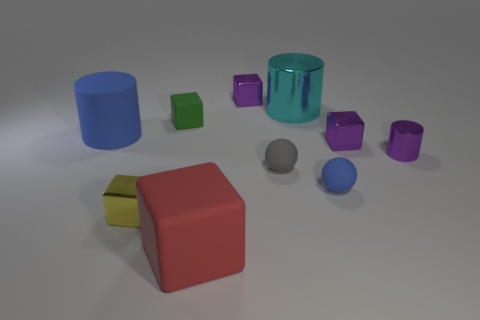How many things are either small shiny things behind the large blue rubber cylinder or gray matte objects?
Give a very brief answer. 2. There is a small metal cylinder; does it have the same color as the tiny metal object behind the large blue thing?
Your answer should be very brief. Yes. How big is the purple thing left of the tiny sphere to the left of the blue matte sphere?
Ensure brevity in your answer.  Small. How many things are either tiny blue matte cylinders or small metal things that are in front of the small matte block?
Give a very brief answer. 3. There is a tiny rubber object that is behind the small gray rubber thing; is it the same shape as the large cyan object?
Your answer should be very brief. No. What number of large cyan metal cylinders are in front of the shiny cylinder in front of the tiny rubber thing that is on the left side of the red object?
Provide a short and direct response. 0. What number of objects are either cyan metallic cylinders or small rubber blocks?
Offer a terse response. 2. There is a tiny yellow object; is it the same shape as the large thing that is in front of the tiny purple cylinder?
Give a very brief answer. Yes. The blue matte object that is to the left of the green object has what shape?
Your answer should be very brief. Cylinder. Is the shape of the small green thing the same as the big red object?
Offer a very short reply. Yes. 